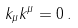<formula> <loc_0><loc_0><loc_500><loc_500>k _ { \mu } k ^ { \mu } = 0 \, .</formula> 